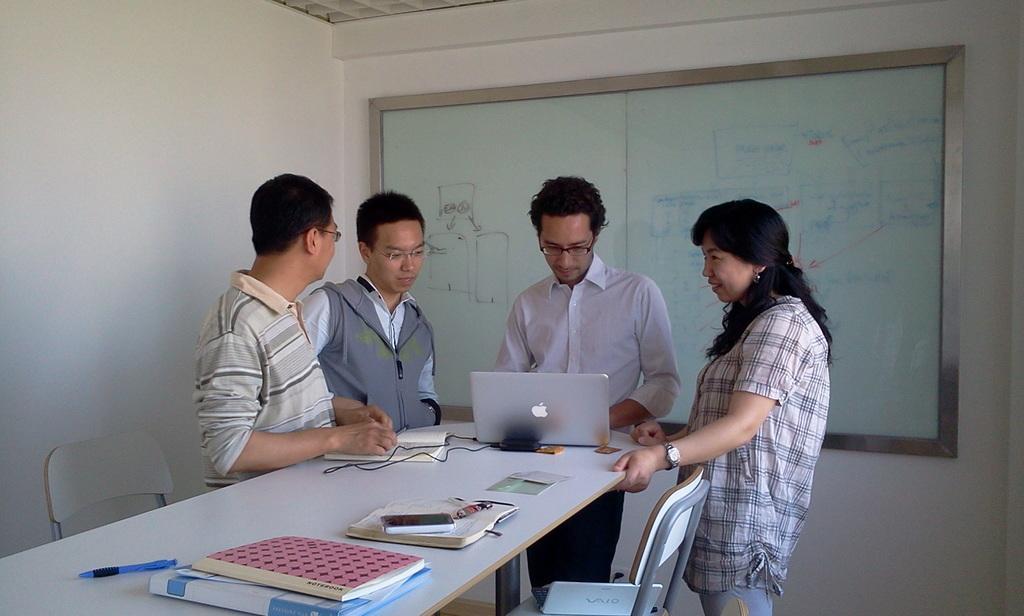Please provide a concise description of this image. In the image there is a table, on the table there are files, books, laptop and other objects. Around the table four people are standing and there are two chairs on the either side of the table, in the background there is a glass board and behind the board there is a wall. 